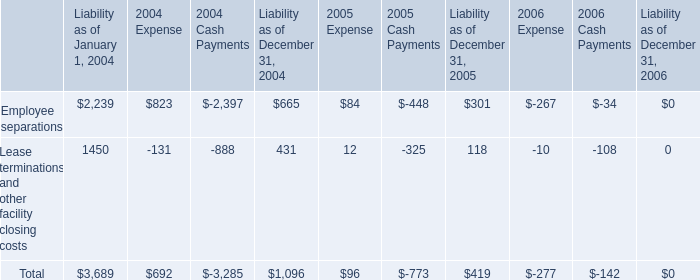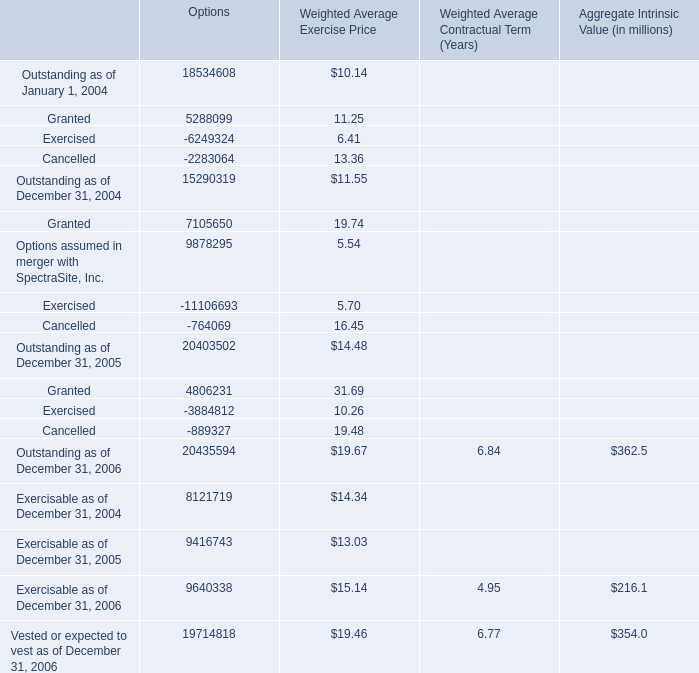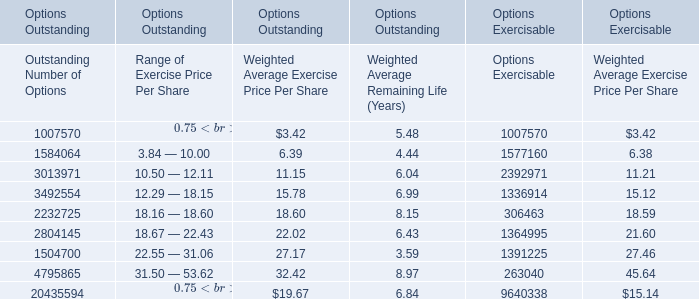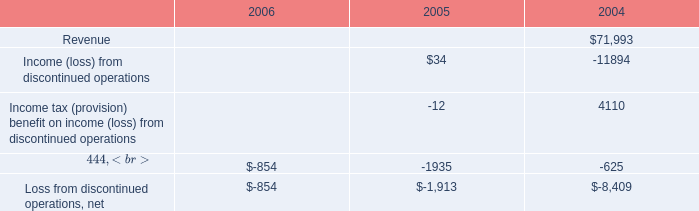What's the sum of 3492554 of Options Exercisable, and Exercisable as of December 31, 2005 of Options ? 
Computations: (1336914.0 + 9416743.0)
Answer: 10753657.0. 